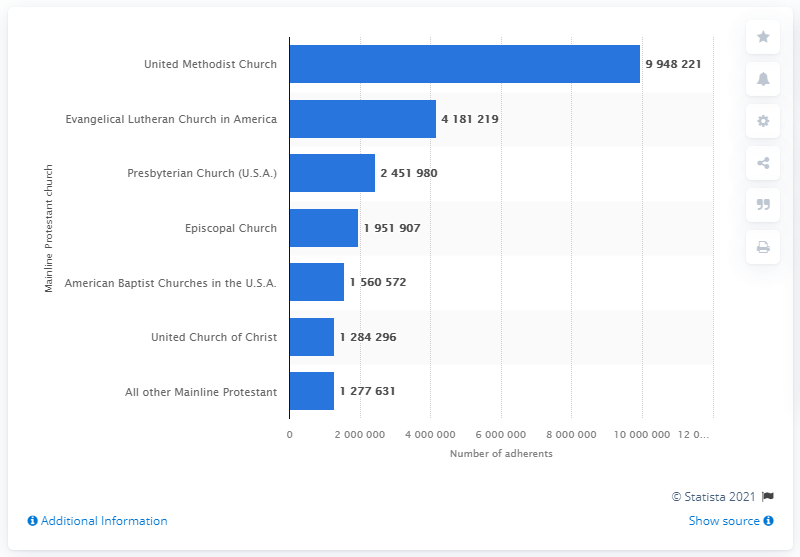Identify some key points in this picture. In 2010, the United Methodist Church was attended by a total of 994,822 people. 